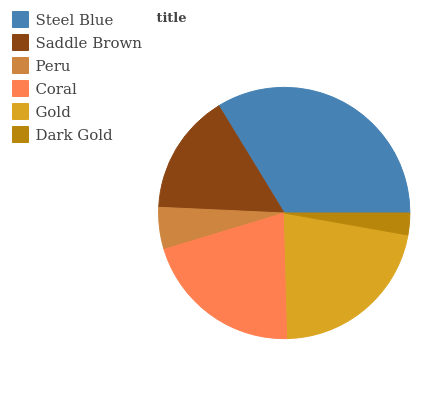Is Dark Gold the minimum?
Answer yes or no. Yes. Is Steel Blue the maximum?
Answer yes or no. Yes. Is Saddle Brown the minimum?
Answer yes or no. No. Is Saddle Brown the maximum?
Answer yes or no. No. Is Steel Blue greater than Saddle Brown?
Answer yes or no. Yes. Is Saddle Brown less than Steel Blue?
Answer yes or no. Yes. Is Saddle Brown greater than Steel Blue?
Answer yes or no. No. Is Steel Blue less than Saddle Brown?
Answer yes or no. No. Is Coral the high median?
Answer yes or no. Yes. Is Saddle Brown the low median?
Answer yes or no. Yes. Is Gold the high median?
Answer yes or no. No. Is Dark Gold the low median?
Answer yes or no. No. 